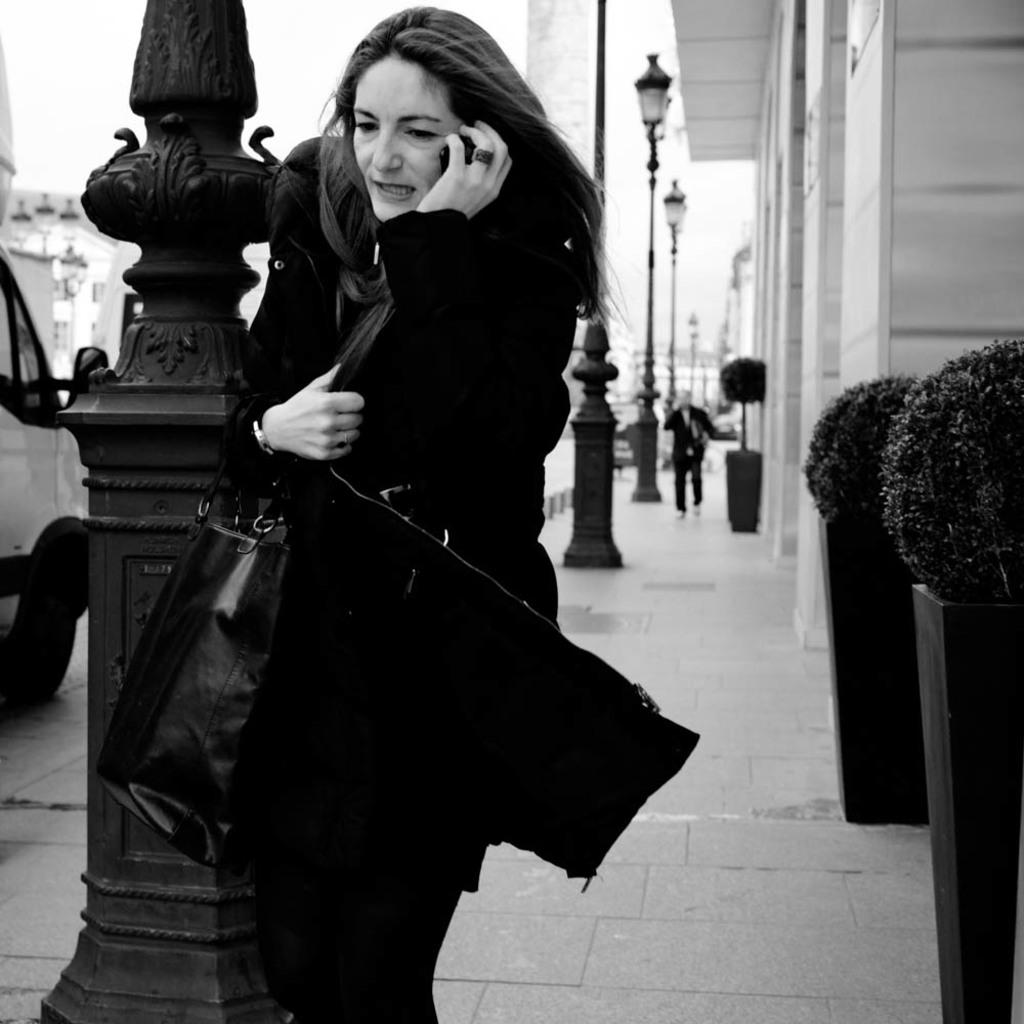What can be seen in the sky in the image? There is a sky in the image, but no specific details about the sky are mentioned. What type of structure is present in the image? There is a building in the image. What type of vegetation is present in the image? There are plants in the image. What type of lighting is present in the image? There are street lamps in the image. What are the two people in the image doing? Two people are walking on a footpath in the image. What type of vehicle is present on the road in the image? A van is present on the road in the image. Where is the drawer located in the image? There is no drawer present in the image. Can you confirm the existence of lace in the image? There is no mention of lace in the image. 